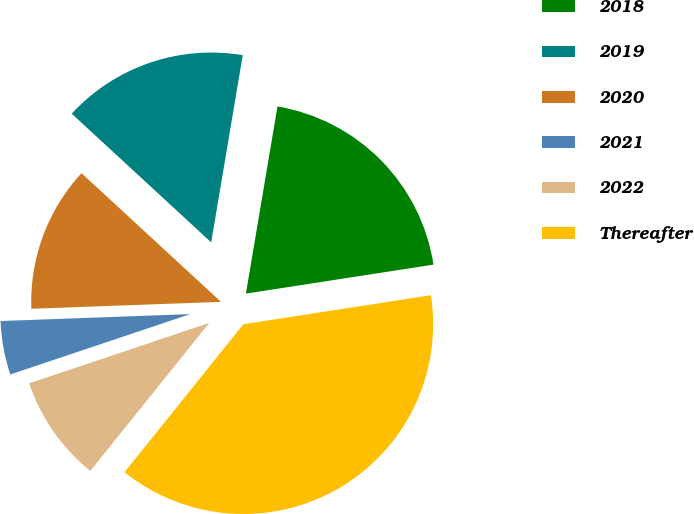Convert chart. <chart><loc_0><loc_0><loc_500><loc_500><pie_chart><fcel>2018<fcel>2019<fcel>2020<fcel>2021<fcel>2022<fcel>Thereafter<nl><fcel>19.9%<fcel>15.8%<fcel>12.44%<fcel>4.57%<fcel>9.08%<fcel>38.21%<nl></chart> 